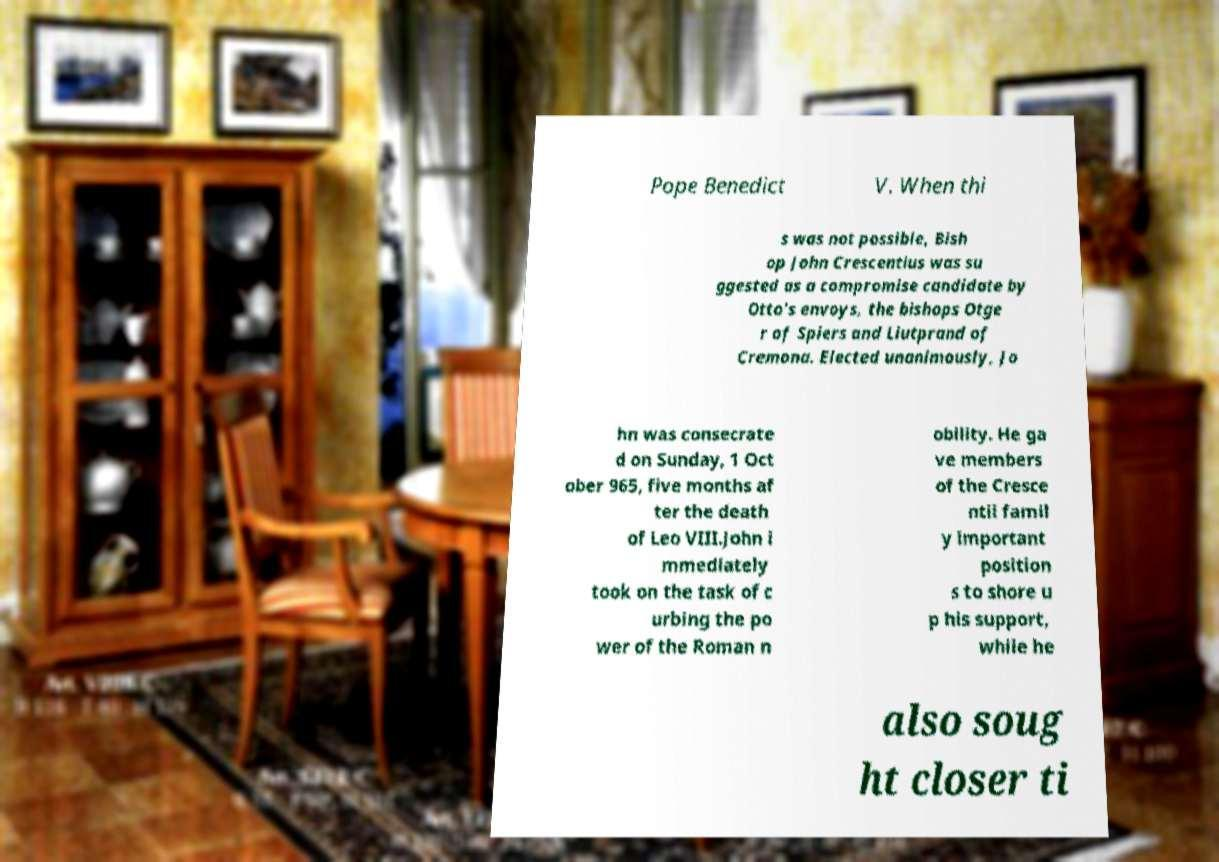Can you read and provide the text displayed in the image?This photo seems to have some interesting text. Can you extract and type it out for me? Pope Benedict V. When thi s was not possible, Bish op John Crescentius was su ggested as a compromise candidate by Otto's envoys, the bishops Otge r of Spiers and Liutprand of Cremona. Elected unanimously, Jo hn was consecrate d on Sunday, 1 Oct ober 965, five months af ter the death of Leo VIII.John i mmediately took on the task of c urbing the po wer of the Roman n obility. He ga ve members of the Cresce ntii famil y important position s to shore u p his support, while he also soug ht closer ti 